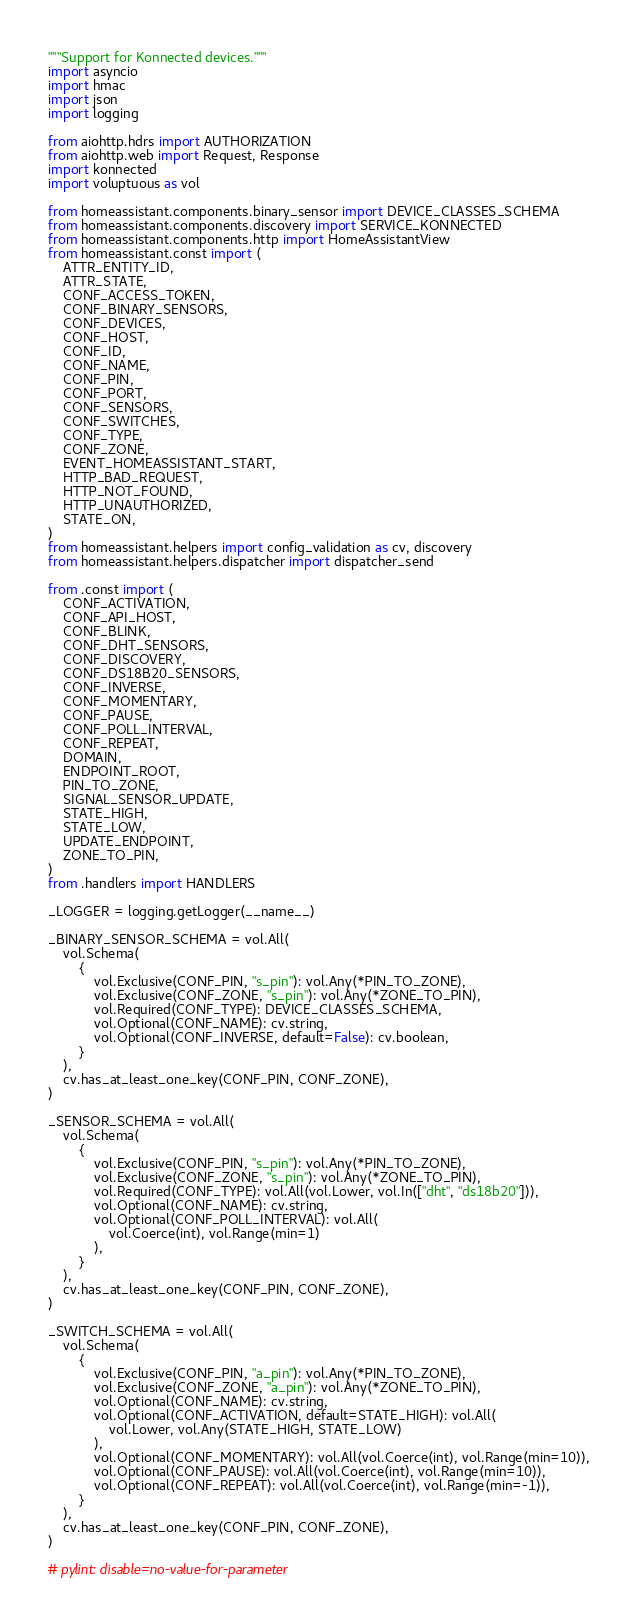Convert code to text. <code><loc_0><loc_0><loc_500><loc_500><_Python_>"""Support for Konnected devices."""
import asyncio
import hmac
import json
import logging

from aiohttp.hdrs import AUTHORIZATION
from aiohttp.web import Request, Response
import konnected
import voluptuous as vol

from homeassistant.components.binary_sensor import DEVICE_CLASSES_SCHEMA
from homeassistant.components.discovery import SERVICE_KONNECTED
from homeassistant.components.http import HomeAssistantView
from homeassistant.const import (
    ATTR_ENTITY_ID,
    ATTR_STATE,
    CONF_ACCESS_TOKEN,
    CONF_BINARY_SENSORS,
    CONF_DEVICES,
    CONF_HOST,
    CONF_ID,
    CONF_NAME,
    CONF_PIN,
    CONF_PORT,
    CONF_SENSORS,
    CONF_SWITCHES,
    CONF_TYPE,
    CONF_ZONE,
    EVENT_HOMEASSISTANT_START,
    HTTP_BAD_REQUEST,
    HTTP_NOT_FOUND,
    HTTP_UNAUTHORIZED,
    STATE_ON,
)
from homeassistant.helpers import config_validation as cv, discovery
from homeassistant.helpers.dispatcher import dispatcher_send

from .const import (
    CONF_ACTIVATION,
    CONF_API_HOST,
    CONF_BLINK,
    CONF_DHT_SENSORS,
    CONF_DISCOVERY,
    CONF_DS18B20_SENSORS,
    CONF_INVERSE,
    CONF_MOMENTARY,
    CONF_PAUSE,
    CONF_POLL_INTERVAL,
    CONF_REPEAT,
    DOMAIN,
    ENDPOINT_ROOT,
    PIN_TO_ZONE,
    SIGNAL_SENSOR_UPDATE,
    STATE_HIGH,
    STATE_LOW,
    UPDATE_ENDPOINT,
    ZONE_TO_PIN,
)
from .handlers import HANDLERS

_LOGGER = logging.getLogger(__name__)

_BINARY_SENSOR_SCHEMA = vol.All(
    vol.Schema(
        {
            vol.Exclusive(CONF_PIN, "s_pin"): vol.Any(*PIN_TO_ZONE),
            vol.Exclusive(CONF_ZONE, "s_pin"): vol.Any(*ZONE_TO_PIN),
            vol.Required(CONF_TYPE): DEVICE_CLASSES_SCHEMA,
            vol.Optional(CONF_NAME): cv.string,
            vol.Optional(CONF_INVERSE, default=False): cv.boolean,
        }
    ),
    cv.has_at_least_one_key(CONF_PIN, CONF_ZONE),
)

_SENSOR_SCHEMA = vol.All(
    vol.Schema(
        {
            vol.Exclusive(CONF_PIN, "s_pin"): vol.Any(*PIN_TO_ZONE),
            vol.Exclusive(CONF_ZONE, "s_pin"): vol.Any(*ZONE_TO_PIN),
            vol.Required(CONF_TYPE): vol.All(vol.Lower, vol.In(["dht", "ds18b20"])),
            vol.Optional(CONF_NAME): cv.string,
            vol.Optional(CONF_POLL_INTERVAL): vol.All(
                vol.Coerce(int), vol.Range(min=1)
            ),
        }
    ),
    cv.has_at_least_one_key(CONF_PIN, CONF_ZONE),
)

_SWITCH_SCHEMA = vol.All(
    vol.Schema(
        {
            vol.Exclusive(CONF_PIN, "a_pin"): vol.Any(*PIN_TO_ZONE),
            vol.Exclusive(CONF_ZONE, "a_pin"): vol.Any(*ZONE_TO_PIN),
            vol.Optional(CONF_NAME): cv.string,
            vol.Optional(CONF_ACTIVATION, default=STATE_HIGH): vol.All(
                vol.Lower, vol.Any(STATE_HIGH, STATE_LOW)
            ),
            vol.Optional(CONF_MOMENTARY): vol.All(vol.Coerce(int), vol.Range(min=10)),
            vol.Optional(CONF_PAUSE): vol.All(vol.Coerce(int), vol.Range(min=10)),
            vol.Optional(CONF_REPEAT): vol.All(vol.Coerce(int), vol.Range(min=-1)),
        }
    ),
    cv.has_at_least_one_key(CONF_PIN, CONF_ZONE),
)

# pylint: disable=no-value-for-parameter</code> 